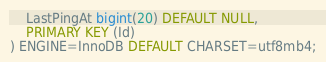Convert code to text. <code><loc_0><loc_0><loc_500><loc_500><_SQL_>    LastPingAt bigint(20) DEFAULT NULL,
    PRIMARY KEY (Id)
) ENGINE=InnoDB DEFAULT CHARSET=utf8mb4;
</code> 